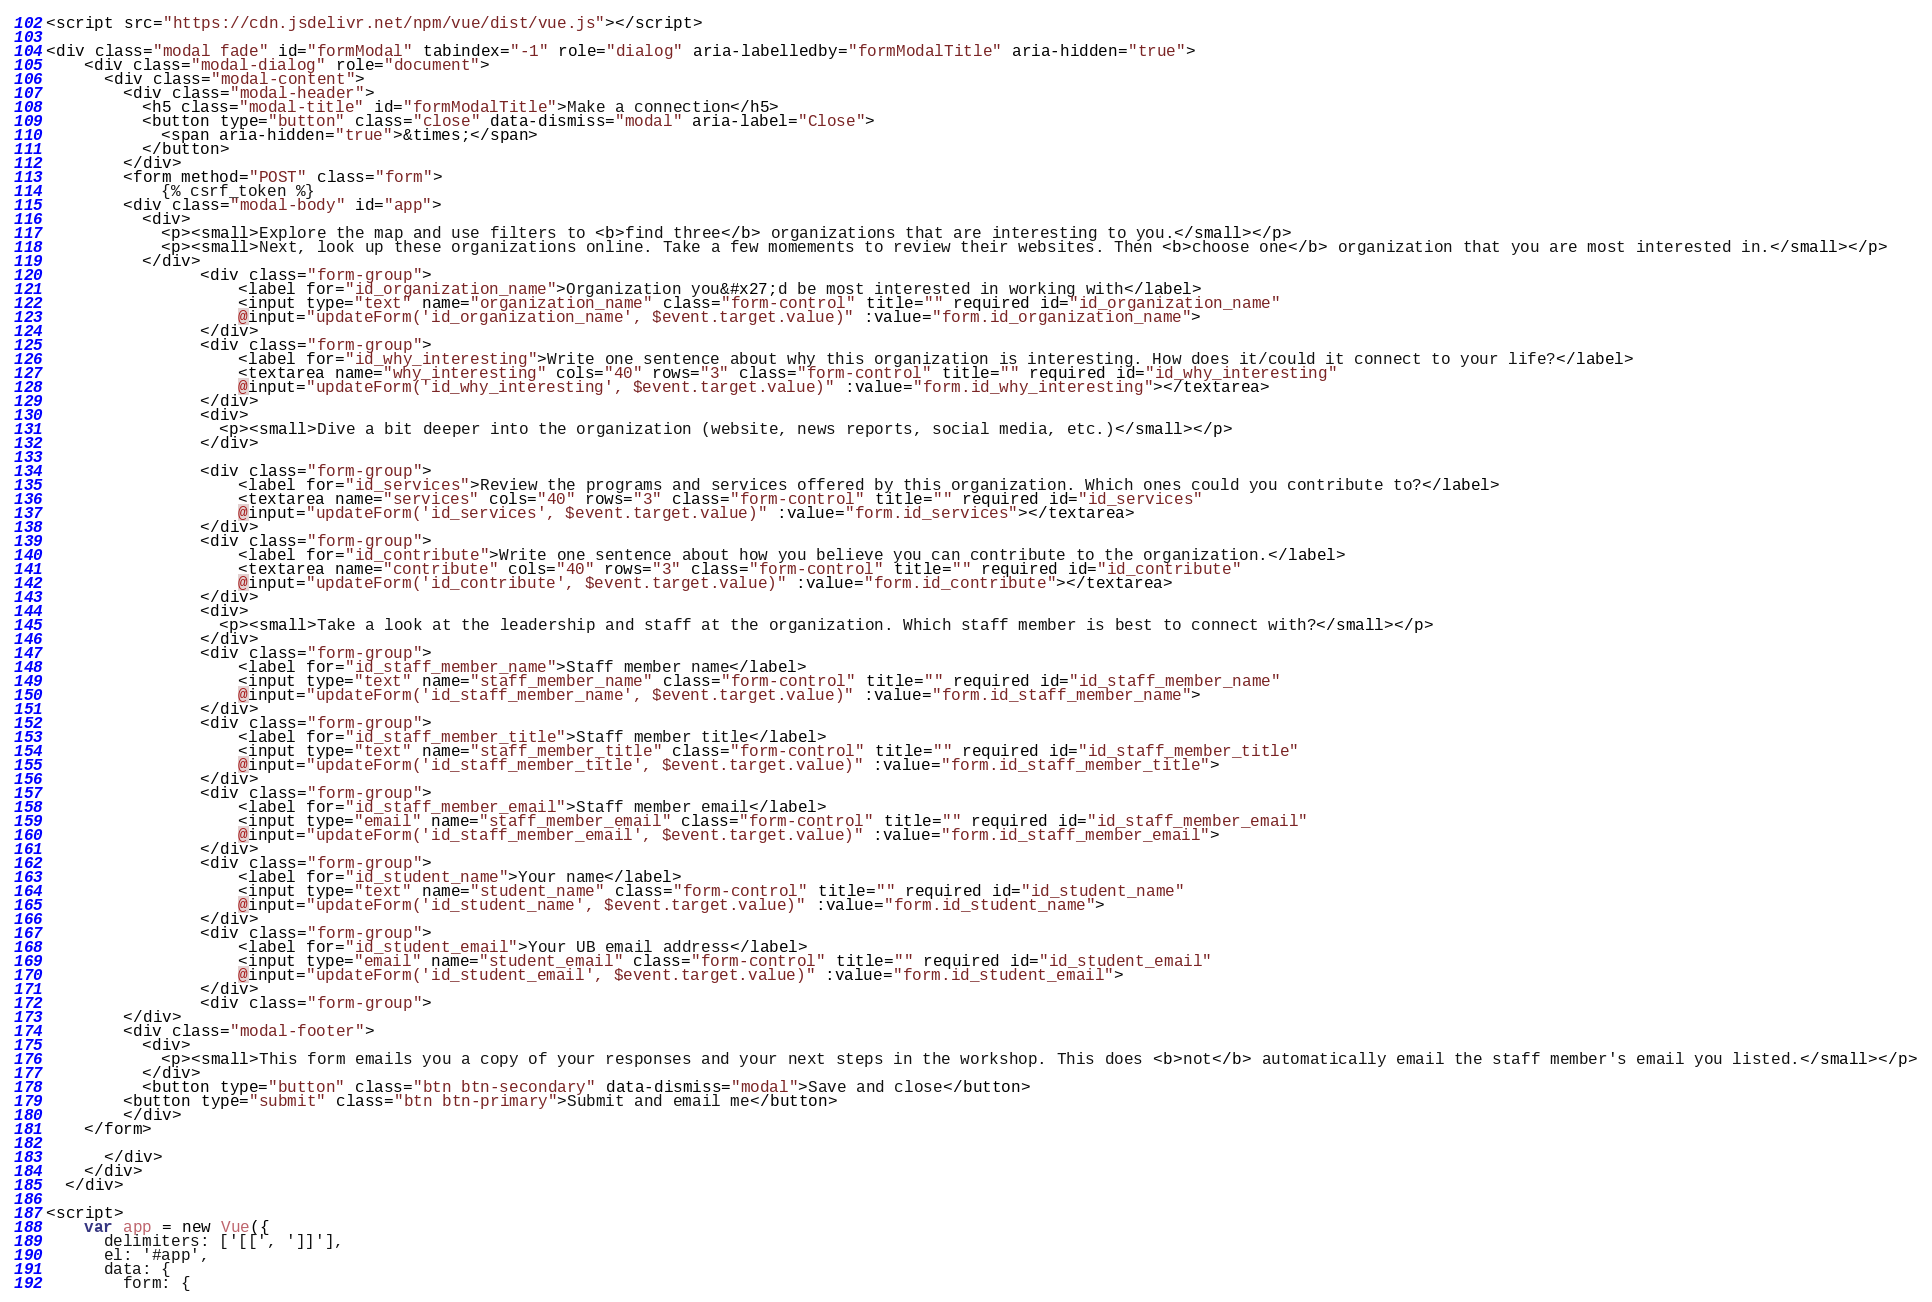Convert code to text. <code><loc_0><loc_0><loc_500><loc_500><_HTML_><script src="https://cdn.jsdelivr.net/npm/vue/dist/vue.js"></script>

<div class="modal fade" id="formModal" tabindex="-1" role="dialog" aria-labelledby="formModalTitle" aria-hidden="true">
    <div class="modal-dialog" role="document">
      <div class="modal-content">
        <div class="modal-header">
          <h5 class="modal-title" id="formModalTitle">Make a connection</h5>
          <button type="button" class="close" data-dismiss="modal" aria-label="Close">
            <span aria-hidden="true">&times;</span>
          </button>
        </div>
        <form method="POST" class="form">
            {% csrf_token %}
        <div class="modal-body" id="app">
          <div>
            <p><small>Explore the map and use filters to <b>find three</b> organizations that are interesting to you.</small></p>
            <p><small>Next, look up these organizations online. Take a few momements to review their websites. Then <b>choose one</b> organization that you are most interested in.</small></p>
          </div>
                <div class="form-group">
                    <label for="id_organization_name">Organization you&#x27;d be most interested in working with</label>
                    <input type="text" name="organization_name" class="form-control" title="" required id="id_organization_name"
                    @input="updateForm('id_organization_name', $event.target.value)" :value="form.id_organization_name">
                </div>
                <div class="form-group">
                    <label for="id_why_interesting">Write one sentence about why this organization is interesting. How does it/could it connect to your life?</label>
                    <textarea name="why_interesting" cols="40" rows="3" class="form-control" title="" required id="id_why_interesting"
                    @input="updateForm('id_why_interesting', $event.target.value)" :value="form.id_why_interesting"></textarea>
                </div>
                <div>
                  <p><small>Dive a bit deeper into the organization (website, news reports, social media, etc.)</small></p>
                </div>
                
                <div class="form-group">
                    <label for="id_services">Review the programs and services offered by this organization. Which ones could you contribute to?</label>
                    <textarea name="services" cols="40" rows="3" class="form-control" title="" required id="id_services"
                    @input="updateForm('id_services', $event.target.value)" :value="form.id_services"></textarea>
                </div>
                <div class="form-group">
                    <label for="id_contribute">Write one sentence about how you believe you can contribute to the organization.</label>
                    <textarea name="contribute" cols="40" rows="3" class="form-control" title="" required id="id_contribute"
                    @input="updateForm('id_contribute', $event.target.value)" :value="form.id_contribute"></textarea>
                </div>
                <div>
                  <p><small>Take a look at the leadership and staff at the organization. Which staff member is best to connect with?</small></p>
                </div>
                <div class="form-group">
                    <label for="id_staff_member_name">Staff member name</label>
                    <input type="text" name="staff_member_name" class="form-control" title="" required id="id_staff_member_name"
                    @input="updateForm('id_staff_member_name', $event.target.value)" :value="form.id_staff_member_name">
                </div>
                <div class="form-group">
                    <label for="id_staff_member_title">Staff member title</label>
                    <input type="text" name="staff_member_title" class="form-control" title="" required id="id_staff_member_title"
                    @input="updateForm('id_staff_member_title', $event.target.value)" :value="form.id_staff_member_title">
                </div>
                <div class="form-group">
                    <label for="id_staff_member_email">Staff member email</label>
                    <input type="email" name="staff_member_email" class="form-control" title="" required id="id_staff_member_email"
                    @input="updateForm('id_staff_member_email', $event.target.value)" :value="form.id_staff_member_email">
                </div>
                <div class="form-group">
                    <label for="id_student_name">Your name</label>
                    <input type="text" name="student_name" class="form-control" title="" required id="id_student_name"
                    @input="updateForm('id_student_name', $event.target.value)" :value="form.id_student_name">
                </div>
                <div class="form-group">
                    <label for="id_student_email">Your UB email address</label>
                    <input type="email" name="student_email" class="form-control" title="" required id="id_student_email"
                    @input="updateForm('id_student_email', $event.target.value)" :value="form.id_student_email">
                </div>
                <div class="form-group">
        </div>
        <div class="modal-footer">
          <div>
            <p><small>This form emails you a copy of your responses and your next steps in the workshop. This does <b>not</b> automatically email the staff member's email you listed.</small></p>
          </div>
          <button type="button" class="btn btn-secondary" data-dismiss="modal">Save and close</button>
        <button type="submit" class="btn btn-primary">Submit and email me</button>
        </div>
    </form>

      </div>
    </div>
  </div>

<script>
    var app = new Vue({
      delimiters: ['[[', ']]'],
      el: '#app',
      data: {
        form: {</code> 